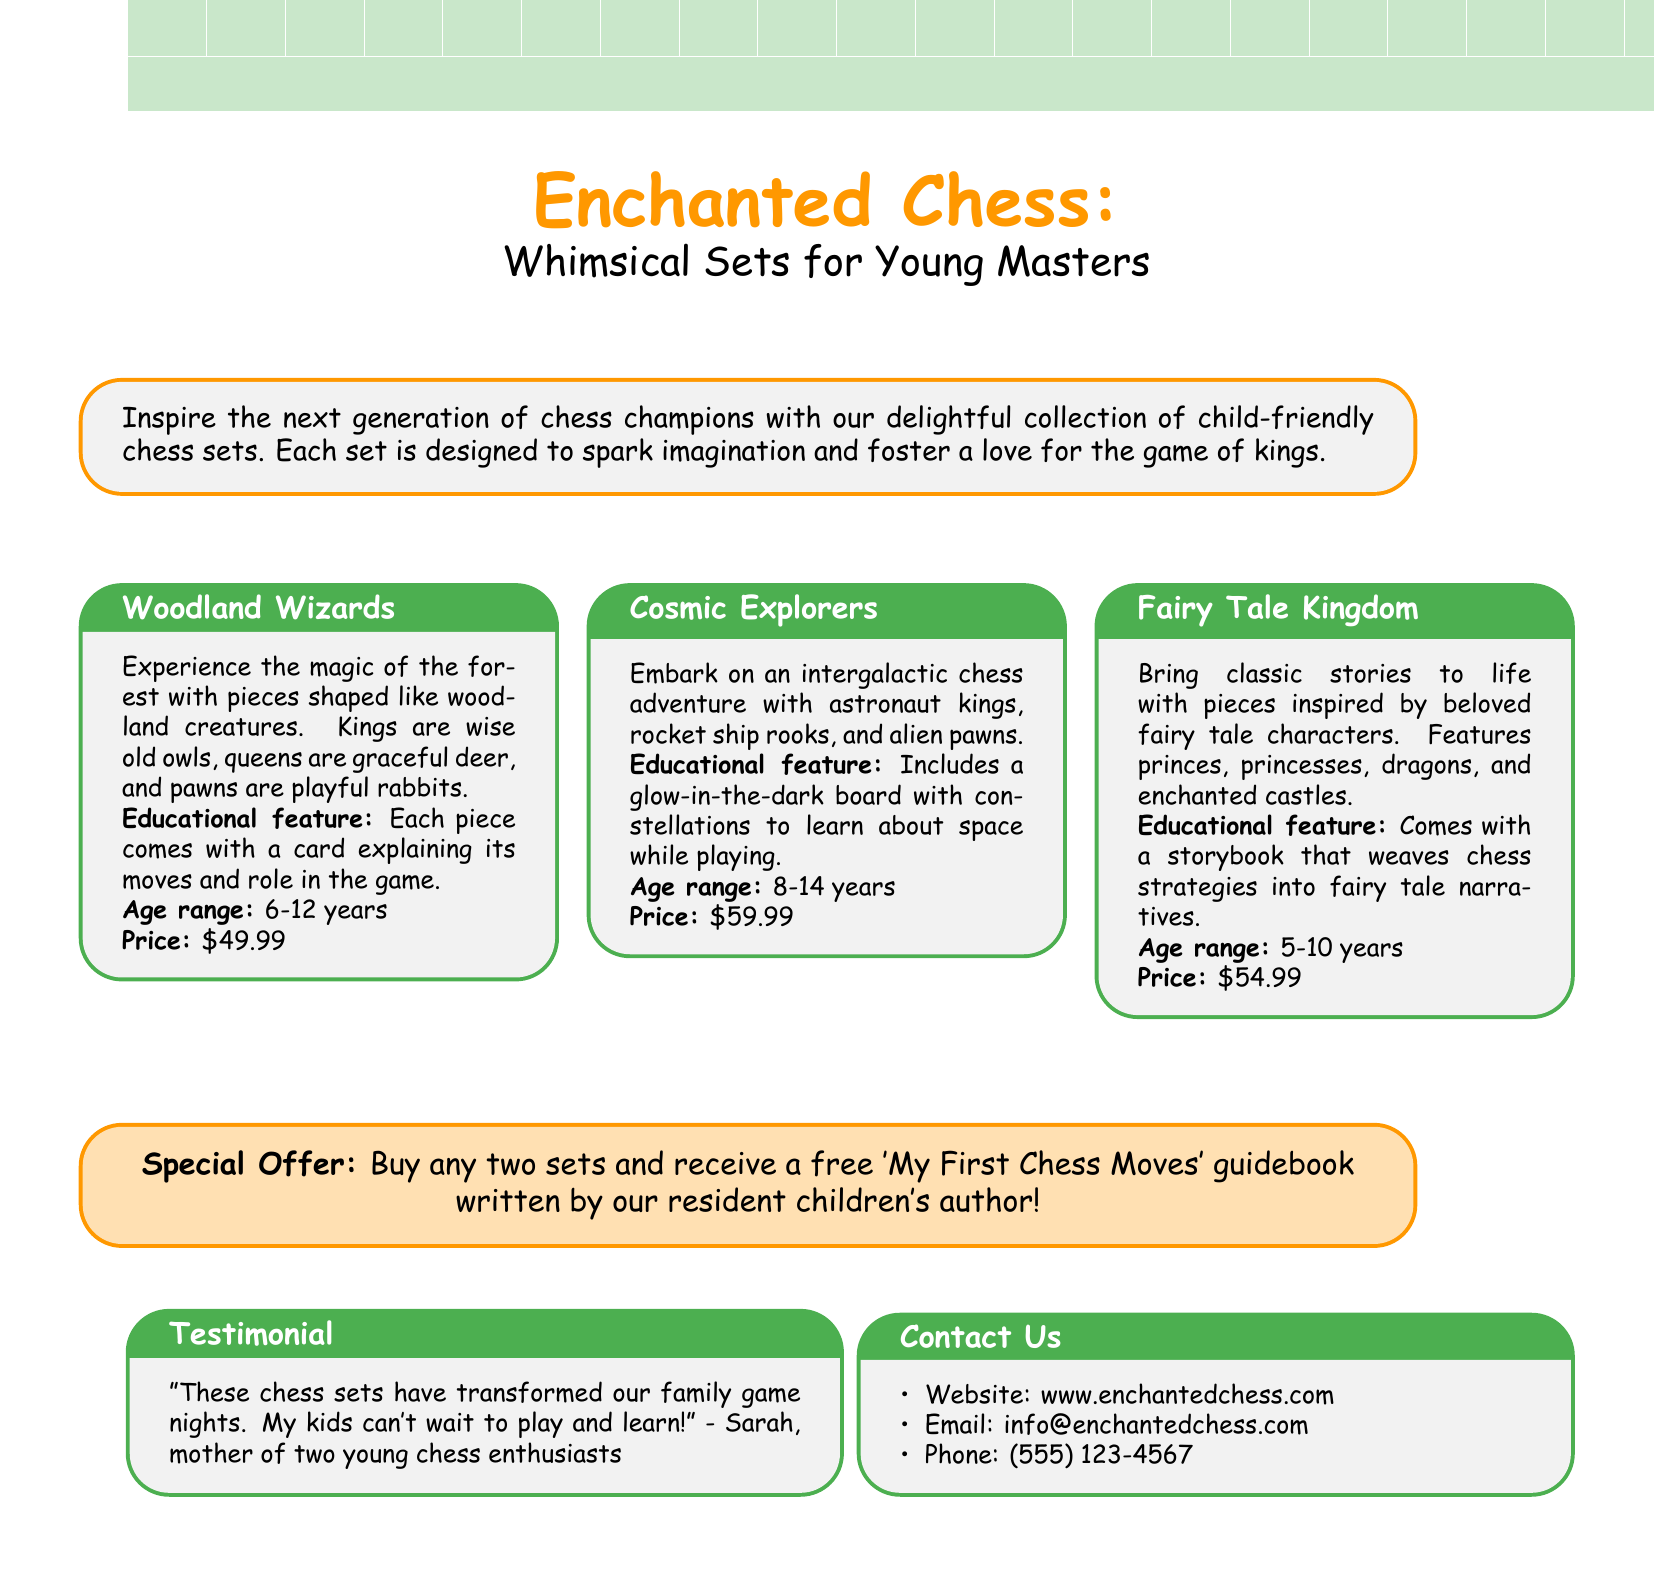What is the title of the catalog? The title of the catalog is prominently displayed at the top of the document.
Answer: Enchanted Chess: Whimsical Sets for Young Masters How many chess sets are showcased in the catalog? The document features three distinct chess sets available for children.
Answer: 3 What is the age range for the Woodland Wizards chess set? The age range is specified in the box for the Woodland Wizards chess set.
Answer: 6-12 years What educational feature is included with the Cosmic Explorers set? The document mentions the educational feature for each set within the description.
Answer: Includes a glow-in-the-dark board What is the price of the Fairy Tale Kingdom set? The price is stated clearly next to each chess set's details.
Answer: $54.99 What is the special offer mentioned in the catalog? The special offer is highlighted in a separate colored box in the document.
Answer: Buy any two sets and receive a free 'My First Chess Moves' guidebook Who provided the testimonial in the catalog? The name of the person giving the testimonial is included in the testimonial box.
Answer: Sarah What type of game does the catalog promote? The overall theme of the document revolves around a specific type of game.
Answer: Chess What design theme do the pieces of the Woodland Wizards set have? The design theme is described in the catalog under the Woodland Wizards section.
Answer: Woodland creatures 